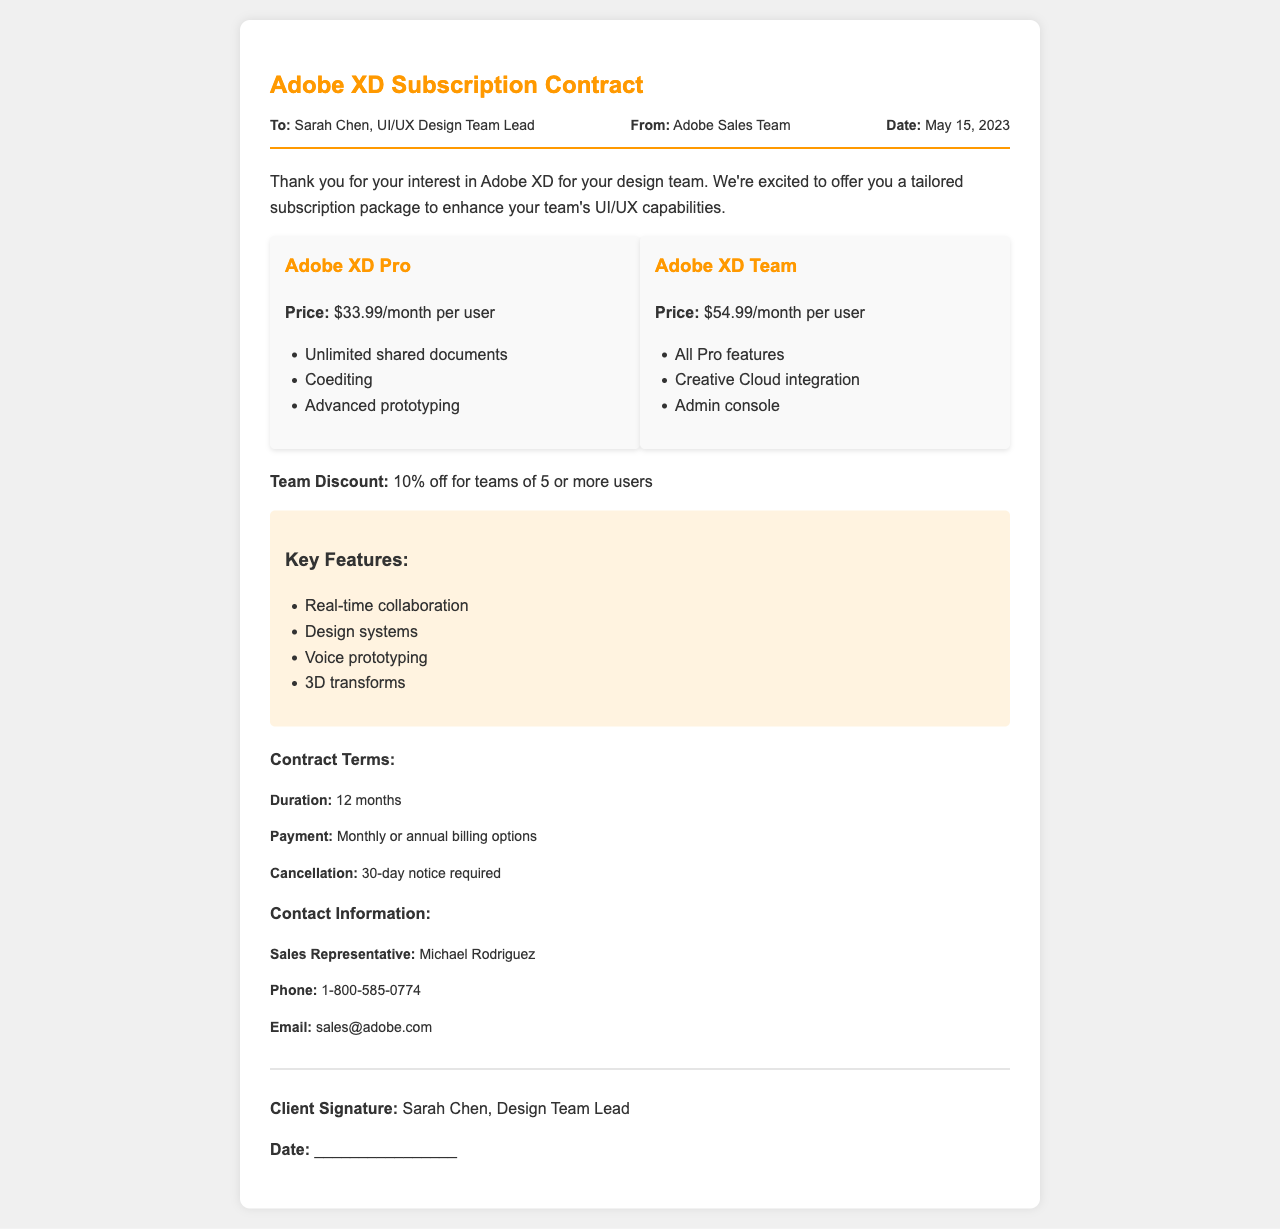What is the price of Adobe XD Pro? The price of Adobe XD Pro is specified in the subscription tier section of the document.
Answer: $33.99/month per user What are the key features listed in the document? Key features are mentioned in a specific section of the document titled "Key Features".
Answer: Real-time collaboration, Design systems, Voice prototyping, 3D transforms Who is the sales representative for this contract? The sales representative's name is provided in the "Contact Information" section.
Answer: Michael Rodriguez What is the duration of the contract? The duration of the contract is explicitly stated in the "Contract Terms" section.
Answer: 12 months Is there a discount for teams? The document mentions a specific discount related to team size within the subscription offer.
Answer: 10% off for teams of 5 or more users What two subscription tiers are offered? The document specifies the names of the two subscription tiers in the "subscription tiers" section.
Answer: Adobe XD Pro, Adobe XD Team What is required for cancellation? The requirements for cancellation are outlined under the "Contract Terms" section of the document.
Answer: 30-day notice required What is the email address for sales inquiries? The email address for contacting sales is listed in the "Contact Information" section.
Answer: sales@adobe.com 